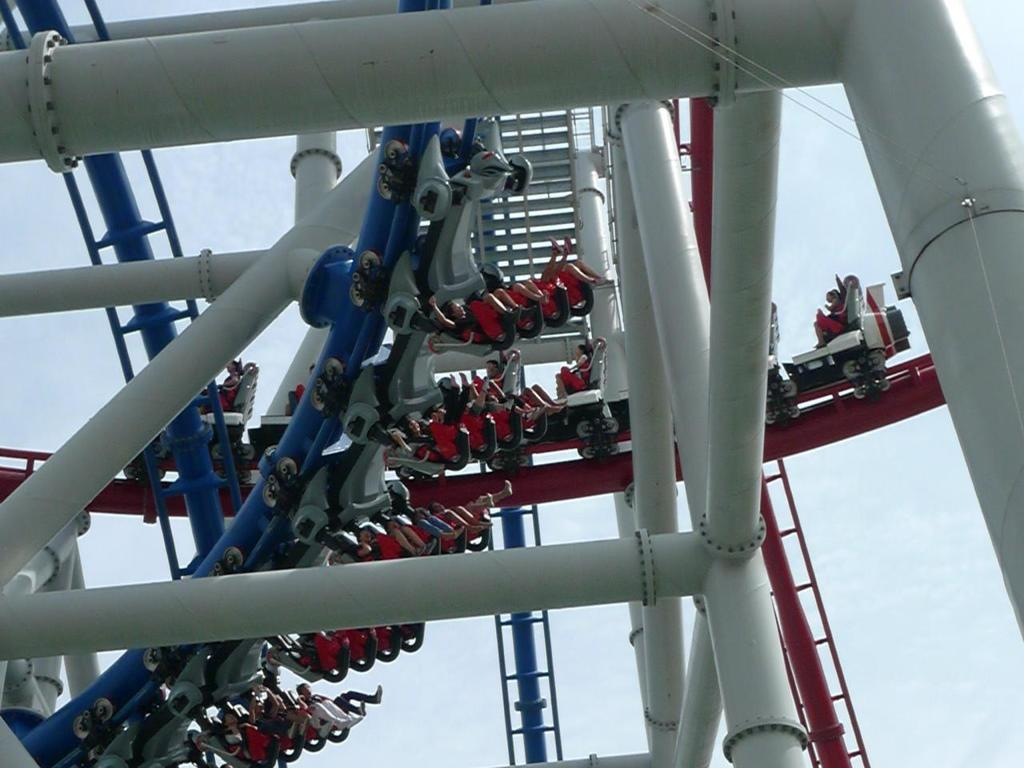Who or what is present in the image? There are people in the image. What are the people doing in the image? The people are riding a roller coaster. What can be seen supporting the roller coaster in the image? There are poles visible in the image. What is visible in the background of the image? The sky is visible in the image. What type of celery is being used as a safety feature on the roller coaster in the image? There is no celery present in the image, and it is not being used as a safety feature on the roller coaster. 